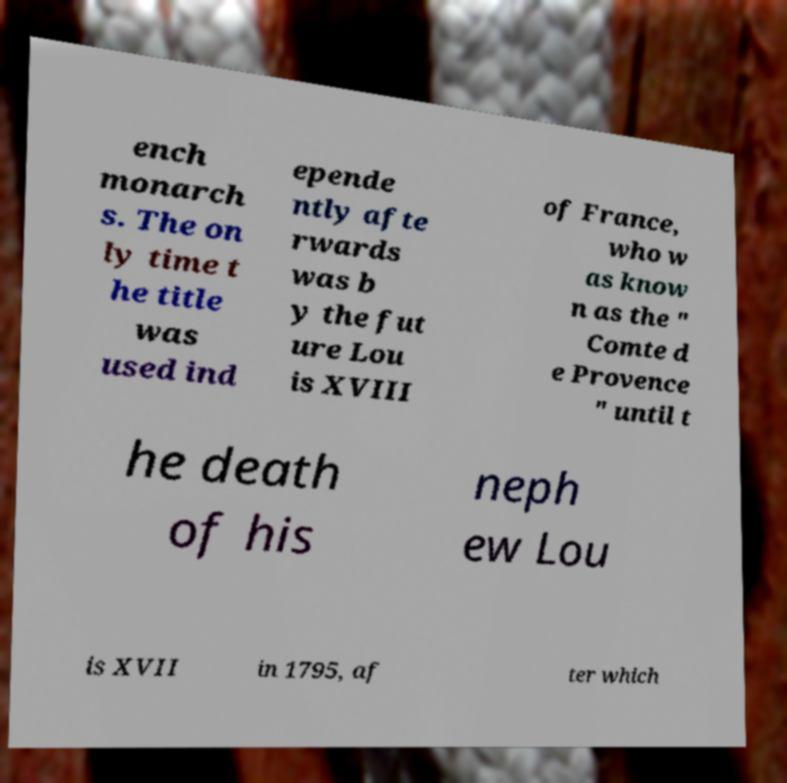Can you accurately transcribe the text from the provided image for me? ench monarch s. The on ly time t he title was used ind epende ntly afte rwards was b y the fut ure Lou is XVIII of France, who w as know n as the " Comte d e Provence " until t he death of his neph ew Lou is XVII in 1795, af ter which 